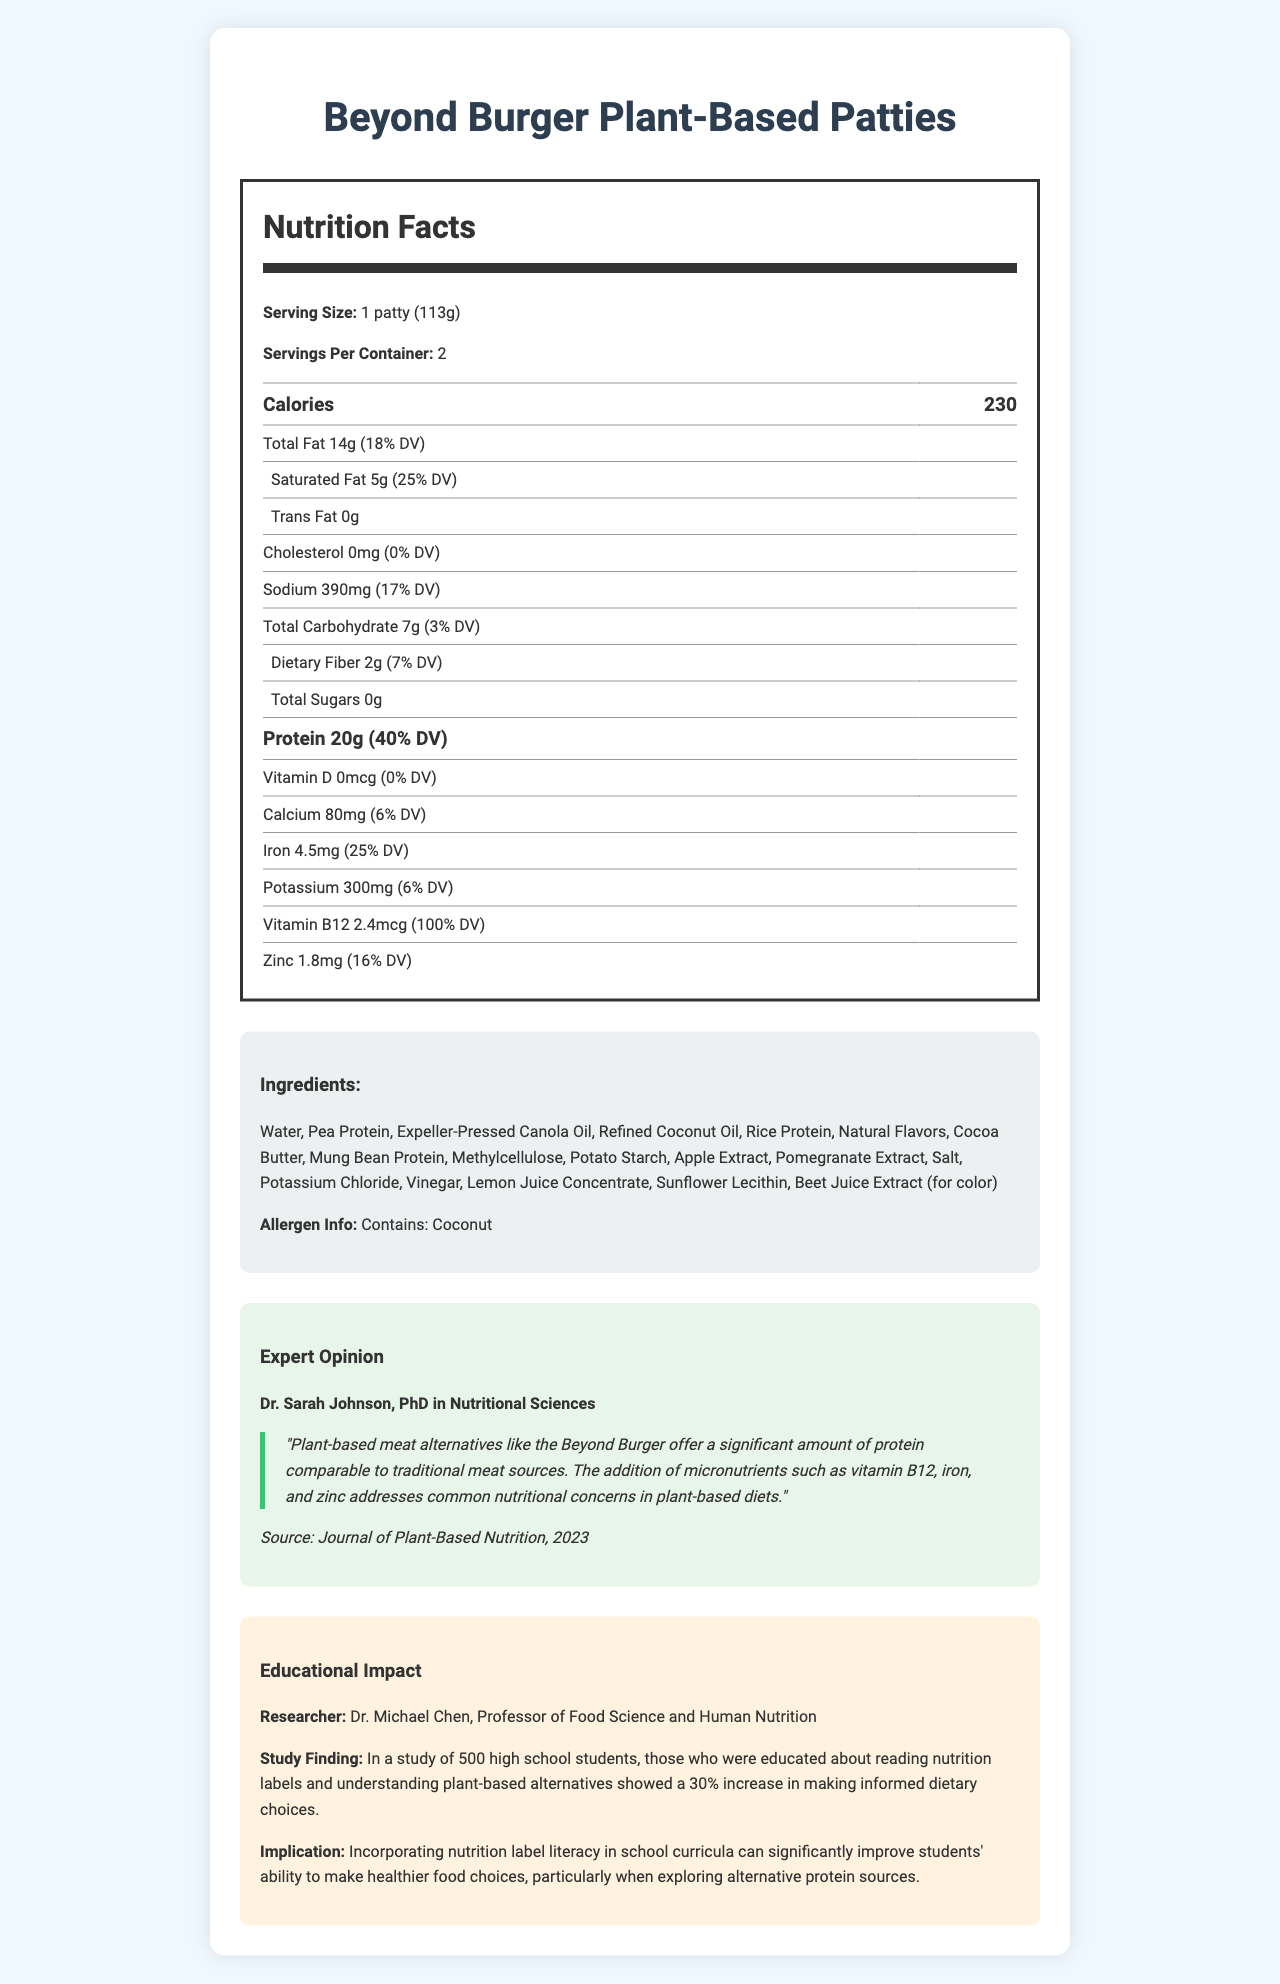What is the serving size for Beyond Burger Plant-Based Patties? The serving size is explicitly listed as 1 patty (113g).
Answer: 1 patty (113g) What is the total fat content per serving, and what percentage of the daily value does it represent? The total fat content per serving is 14g, and it represents 18% of the daily value.
Answer: 14g, 18% How much protein is in each serving of the Beyond Burger Plant-Based Patties? The protein content per serving is directly listed as 20g.
Answer: 20g Which micronutrient in the Beyond Burger Plant-Based Patties meets 100% of the daily value recommendation? The Vitamin B12 content is listed at 100% daily value.
Answer: Vitamin B12 Does the Beyond Burger Plant-Based Patties contain trans fat? The trans fat amount is listed as 0g, indicating no trans fat content.
Answer: No What is the calorie count per serving of Beyond Burger Plant-Based Patties? The calorie count per serving is listed as 230.
Answer: 230 calories Which of these micronutrients are found in the Beyond Burger Plant-Based Patties? A. Vitamin C, B. Vitamin B12, C. Magnesium, D. Thiamine The listed micronutrients include Vitamin B12 but not Vitamin C, Magnesium, or Thiamine.
Answer: B. Vitamin B12 What is the key ingredient responsible for the protein content in the Beyond Burger Plant-Based Patties? A. Water, B. Pea Protein, C. Coconut Oil, D. Mung Bean Protein Pea Protein is one of the primary ingredients mentioned, responsible for the protein content.
Answer: B. Pea Protein How many servings are there per container of Beyond Burger Plant-Based Patties? The document states there are 2 servings per container.
Answer: 2 Is coconut an allergen contained in the Beyond Burger Plant-Based Patties? The allergen information states it contains coconut.
Answer: Yes What did Dr. Sarah Johnson highlight about the Beyond Burger in her expert opinion? This is directly taken from the quoted expert opinion in the document.
Answer: Dr. Sarah Johnson emphasized the significant protein amount and the inclusion of micronutrients like vitamin B12, iron, and zinc, which address common nutritional concerns in plant-based diets. Can the nutritional content of the Beyond Burger help address deficiencies commonly seen in plant-based diets? The inclusion of vitamin B12, iron, and zinc helps address common nutritional deficiencies in plant-based diets according to Dr. Sarah Johnson’s opinion.
Answer: Yes Explain the significance of the study finding by Dr. Michael Chen in the context of educational impact. The study conducted by Dr. Michael Chen illustrated that nutritional education can significantly enhance students' ability to make informed food choices, particularly with alternative protein sources like those found in plant-based meat alternatives.
Answer: Dr. Michael Chen's study found that educating high school students about reading nutrition labels and understanding plant-based alternatives led to a 30% increase in making informed dietary choices. The implication is that incorporating nutrition label literacy in school curricula can significantly improve students' ability to make healthier food choices. What is the micronutrient amount that directly helps with vitamin D intake in the Beyond Burger Plant-Based Patties? The document shows the vitamin D content as 0 mcg, representing 0% of the daily value.
Answer: 0 mcg, 0% Based on the data, would it be accurate to say that the Beyond Burger Plant-Based Patties contain a high amount of total sugars? The total sugars amount listed is 0g, indicating it does not contain a meaningful amount.
Answer: No Summarize the main idea of the document. The document covers the detailed nutritional analysis, ingredients, allergen info, expert opinions, and the educational implications of teaching nutrition label literacy, particularly in the context of plant-based diets.
Answer: The document provides comprehensive nutrition information about the Beyond Burger Plant-Based Patties, highlighting their protein content and contribution to daily micronutrient intake. It includes an expert opinion from Dr. Sarah Johnson on the nutritional benefits and addresses educational impacts through a study by Dr. Michael Chen on label literacy and informed dietary choices. What is the percentage of the daily value for potassium in each serving of the Beyond Burger Plant-Based Patties? The potassium content is listed as 300mg, with a daily value percentage of 6%.
Answer: 6% What color is added to the Beyond Burger Plant-Based Patties using beet juice extract? Beet juice extract is used for color, and beet juice typically provides a red color.
Answer: Red 